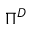Convert formula to latex. <formula><loc_0><loc_0><loc_500><loc_500>\Pi ^ { D }</formula> 